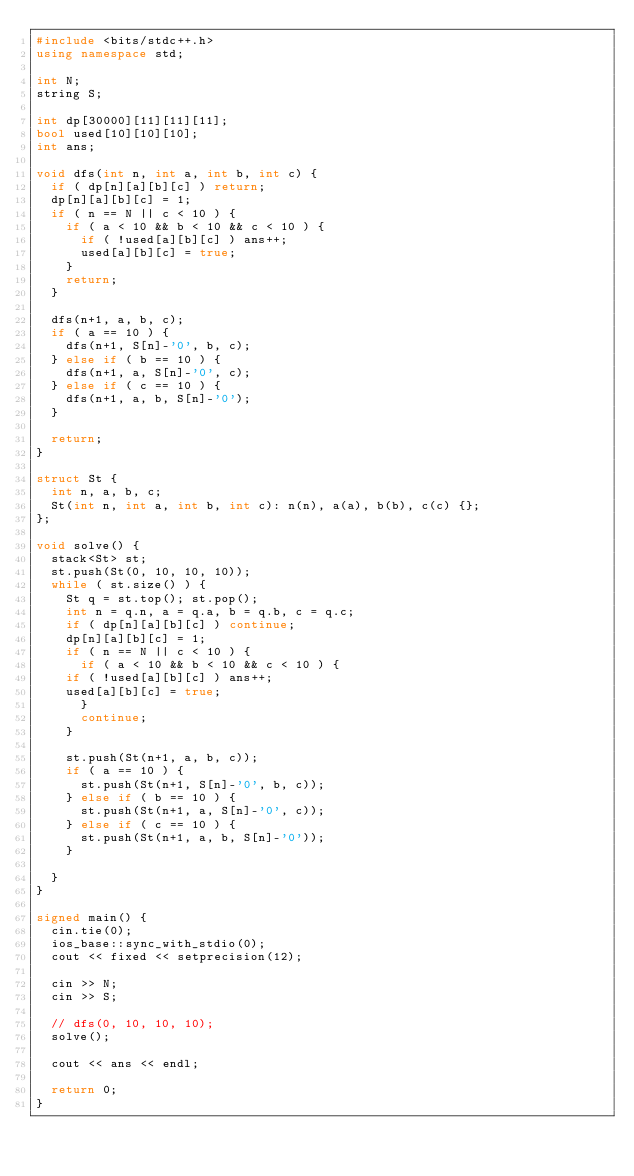<code> <loc_0><loc_0><loc_500><loc_500><_C++_>#include <bits/stdc++.h>
using namespace std;

int N;
string S;

int dp[30000][11][11][11];
bool used[10][10][10];
int ans;

void dfs(int n, int a, int b, int c) {
  if ( dp[n][a][b][c] ) return;
  dp[n][a][b][c] = 1;  
  if ( n == N || c < 10 ) {
    if ( a < 10 && b < 10 && c < 10 ) {
      if ( !used[a][b][c] ) ans++;
      used[a][b][c] = true;
    }
    return;
  }

  dfs(n+1, a, b, c);  
  if ( a == 10 ) {
    dfs(n+1, S[n]-'0', b, c);
  } else if ( b == 10 ) {
    dfs(n+1, a, S[n]-'0', c);
  } else if ( c == 10 ) {
    dfs(n+1, a, b, S[n]-'0');
  }

  return;
}

struct St {
  int n, a, b, c;
  St(int n, int a, int b, int c): n(n), a(a), b(b), c(c) {};  
};

void solve() {
  stack<St> st;  
  st.push(St(0, 10, 10, 10));
  while ( st.size() ) {
    St q = st.top(); st.pop();
    int n = q.n, a = q.a, b = q.b, c = q.c;    
    if ( dp[n][a][b][c] ) continue;
    dp[n][a][b][c] = 1;  
    if ( n == N || c < 10 ) {
      if ( a < 10 && b < 10 && c < 10 ) {
	if ( !used[a][b][c] ) ans++;
	used[a][b][c] = true;
      }
      continue;
    }

    st.push(St(n+1, a, b, c));    
    if ( a == 10 ) {
      st.push(St(n+1, S[n]-'0', b, c));
    } else if ( b == 10 ) {
      st.push(St(n+1, a, S[n]-'0', c));
    } else if ( c == 10 ) {
      st.push(St(n+1, a, b, S[n]-'0'));
    }
  
  }
}

signed main() {
  cin.tie(0);
  ios_base::sync_with_stdio(0);
  cout << fixed << setprecision(12);

  cin >> N;
  cin >> S;

  // dfs(0, 10, 10, 10);
  solve();  

  cout << ans << endl;
  
  return 0;
}
</code> 